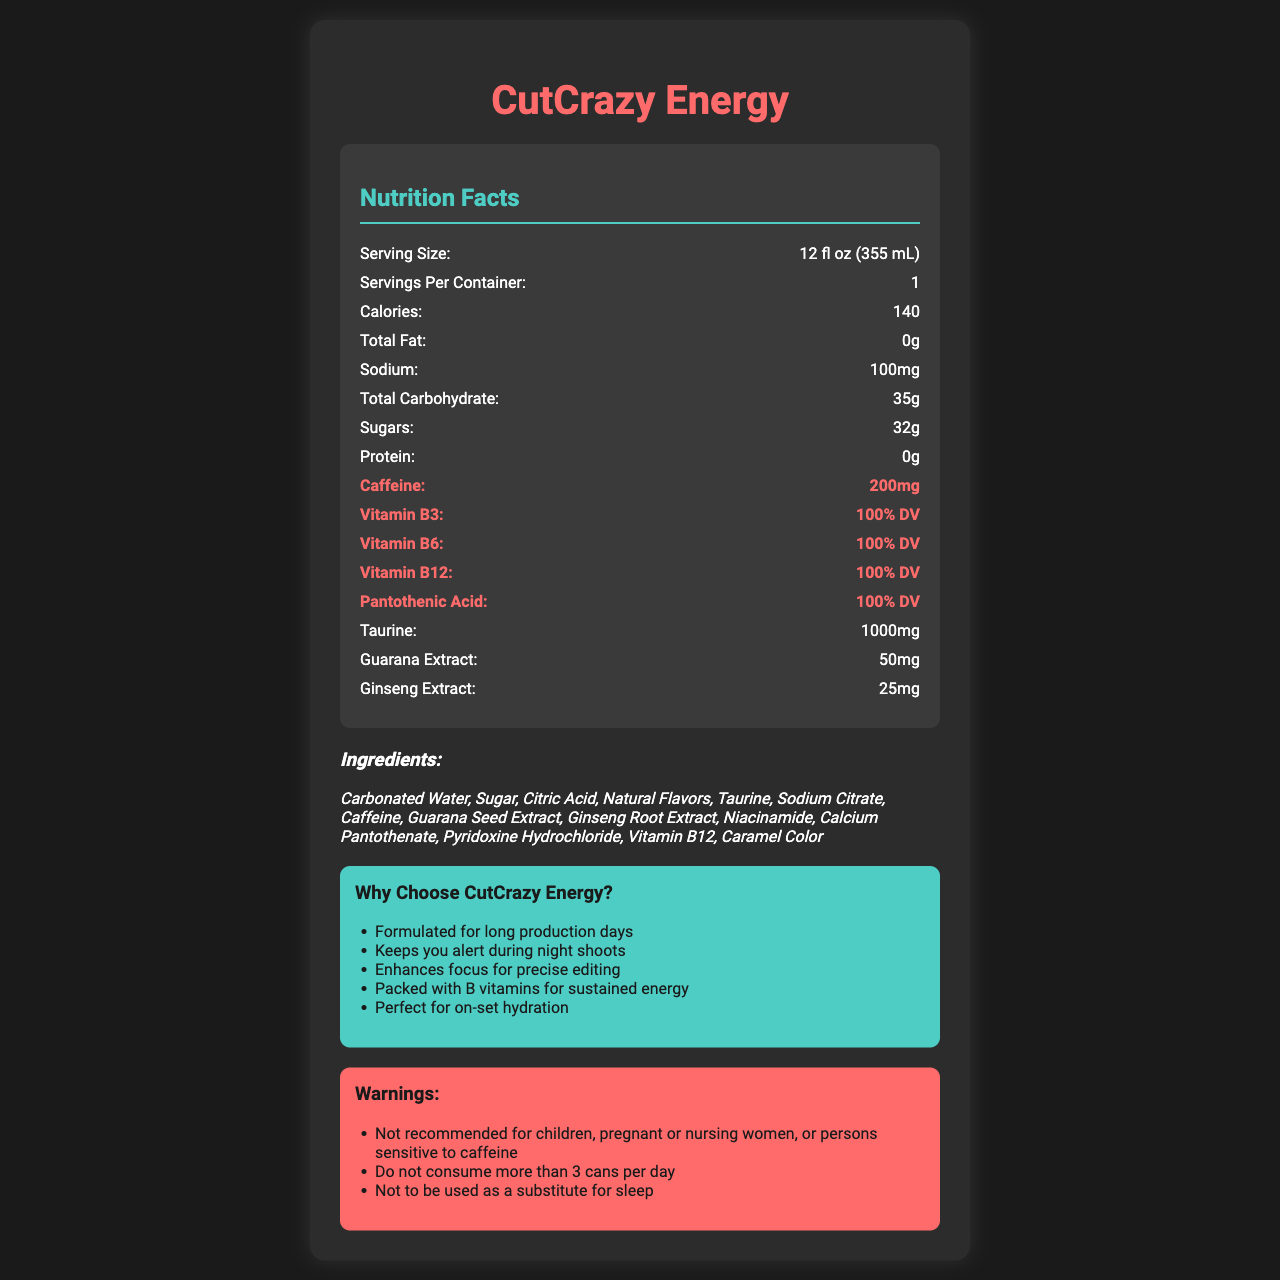what is the serving size? The serving size is explicitly stated as "12 fl oz (355 mL)" in the nutrition facts section of the document.
Answer: 12 fl oz (355 mL) how much caffeine is in one serving? The document highlights the caffeine content in one serving as 200 mg.
Answer: 200 mg what percentage of the daily value for vitamin B6 does one serving provide? The document specifies that one serving provides 100% of the daily value for vitamin B6.
Answer: 100% DV name two herbal extracts included in the ingredients list. The ingredients list includes both "Guarana Seed Extract" and "Ginseng Root Extract".
Answer: Guarana Seed Extract and Ginseng Root Extract how many grams of sugars are in one can? The document lists the sugars content as 32 grams per serving.
Answer: 32 g how many calories are in one serving? The nutrition facts state that there are 140 calories in one serving.
Answer: 140 select the correct sodium content in one serving from the following options: A. 50 mg B. 100 mg C. 200 mg D. 150 mg The sodium content is listed as 100 mg per serving.
Answer: B. 100 mg which of the following marketing claims is *not* mentioned in the document? A. Boosts Immunity B. Formulated for long production days C. Keeps you alert during night shoots D. Enhances focus for precise editing The marketing claims mentioned are "Formulated for long production days," "Keeps you alert during night shoots," and "Enhances focus for precise editing," but there is no mention of boosting immunity.
Answer: A. Boosts Immunity is the product recommended for children? The warnings section explicitly states that the product is "Not recommended for children."
Answer: No summarize the main features of "CutCrazy Energy" The document highlights nutritional information, ingredients, marketing claims, warnings, and TV production tie-ins to provide a comprehensive overview of the product.
Answer: "CutCrazy Energy" is an energy drink designed for TV production crews, offering 140 calories per 12 fl oz serving. It's rich in caffeine (200 mg) and B vitamins (100% DV for B3, B6, B12, and Pantothenic Acid) and includes ingredients like taurine and herbal extracts such as guarana and ginseng. It's marketed with claims to keep users alert, enhance focus, and sustain energy during long production days and night shoots. The can design and flavors are inspired by TV genres. Warnings advise against consumption by children, pregnant women, and those sensitive to caffeine. how many grams of protein are there in one serving? The document specifies that one serving contains 0 grams of protein.
Answer: 0 g how many servings per container does "CutCrazy Energy" have? According to the nutrition facts, there is 1 serving per container.
Answer: 1 what are the possible flavors inspired by TV genres? A. Action Orange B. Romance Raspberry C. Comedy Citrus D. Drama Berry Based on the "TV production tie-ins" section, the possible flavors are "Action Orange," "Comedy Citrus," and "Drama Berry."
Answer: A, C, and D what is the daily value percentage for pantothenic acid in one can? The document indicates that one serving provides 100% of the daily value for pantothenic acid.
Answer: 100% DV how many grams of taurine are in one serving? The document lists the taurine content as 1000 mg per serving.
Answer: 1000 mg describe one of the limitations mentioned in the warnings section. The warnings section contains several limitations, including the recommendation to not consume more than 3 cans per day.
Answer: Do not consume more than 3 cans per day what type of packaging design does "CutCrazy Energy" have? The "TV production tie-ins" section mentions that the can design is camera-shaped.
Answer: Camera-shaped can design how long do the effects from this drink last? The document does not provide information on the duration of the effects from consuming the drink.
Answer: Not enough information 